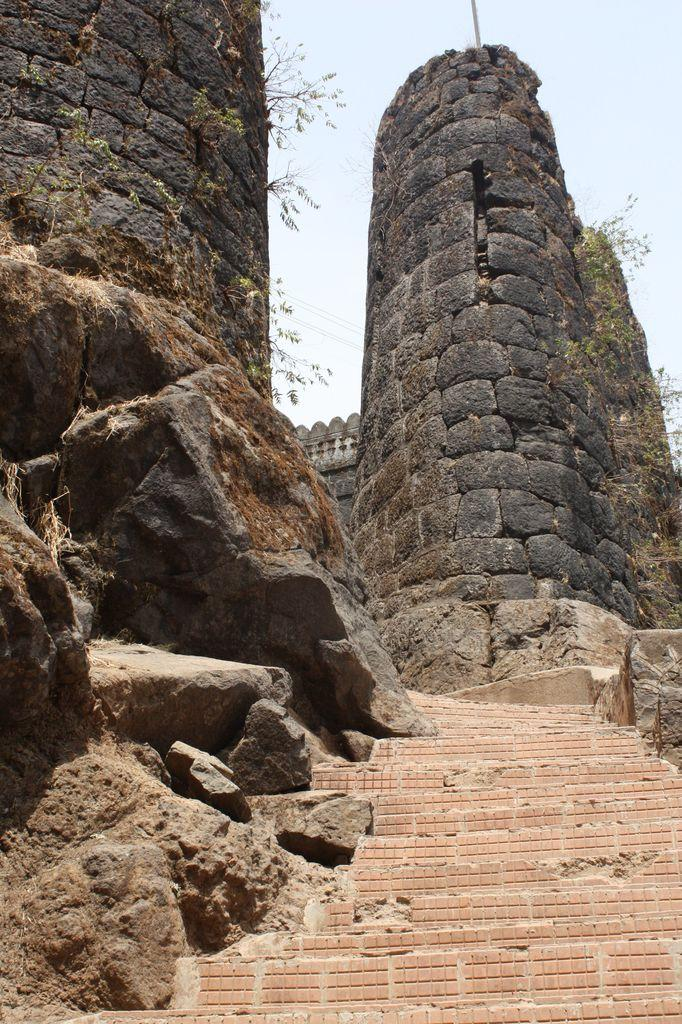What material is used for the steps in the image? There are stones at the steps in the image. What can be seen in the background of the image? There are big walls, plants, a pole, and the sky visible in the background. How many elements can be identified in the background? There are four elements in the background: big walls, plants, a pole, and the sky. What religious symbols can be seen on the walls in the image? There are no religious symbols visible on the walls in the image. Are the people in the image going on vacation? There are no people present in the image, so it cannot be determined if they are going on vacation. 